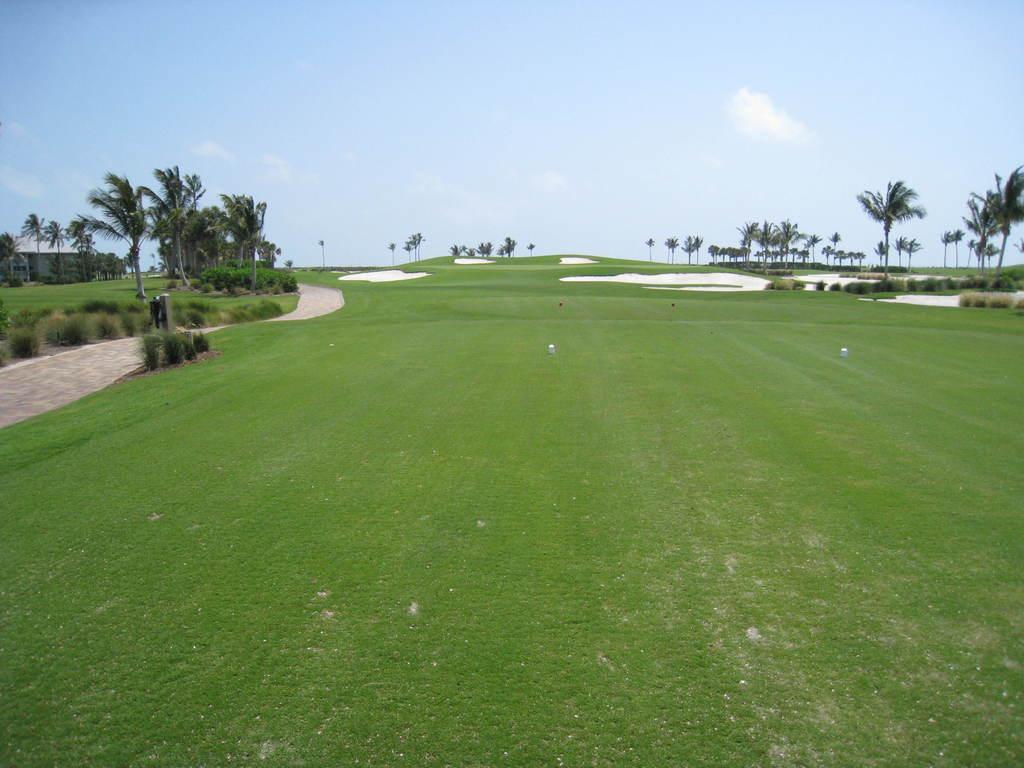Can you describe this image briefly? In this image I see the green grass and I see the plants and in the background I see number of trees and I see the clear sky. 